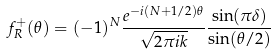Convert formula to latex. <formula><loc_0><loc_0><loc_500><loc_500>f _ { R } ^ { + } ( \theta ) = ( - 1 ) ^ { N } \frac { e ^ { - i ( N + 1 / 2 ) \theta } } { \sqrt { 2 \pi i k } } \frac { \sin ( \pi \delta ) } { \sin ( \theta / 2 ) }</formula> 